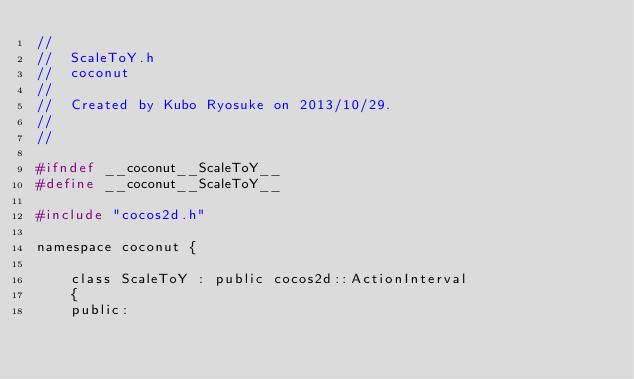Convert code to text. <code><loc_0><loc_0><loc_500><loc_500><_C_>//
//  ScaleToY.h
//  coconut
//
//  Created by Kubo Ryosuke on 2013/10/29.
//
//

#ifndef __coconut__ScaleToY__
#define __coconut__ScaleToY__

#include "cocos2d.h"

namespace coconut {

	class ScaleToY : public cocos2d::ActionInterval
	{
	public:</code> 